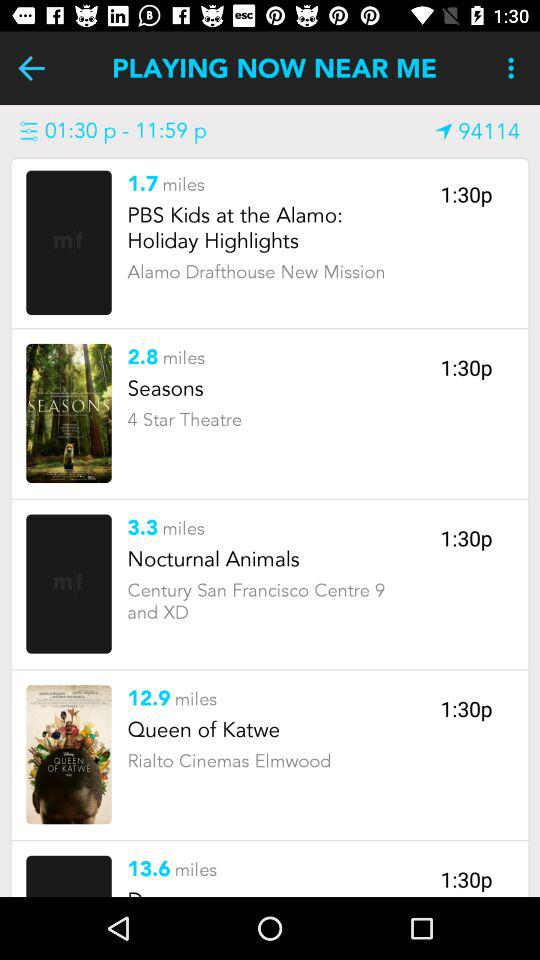Where is "Nocturnal Animals" playing? The "Nocturnal Animals" is playing at "Century San Francisco Centre 9 and XD". 